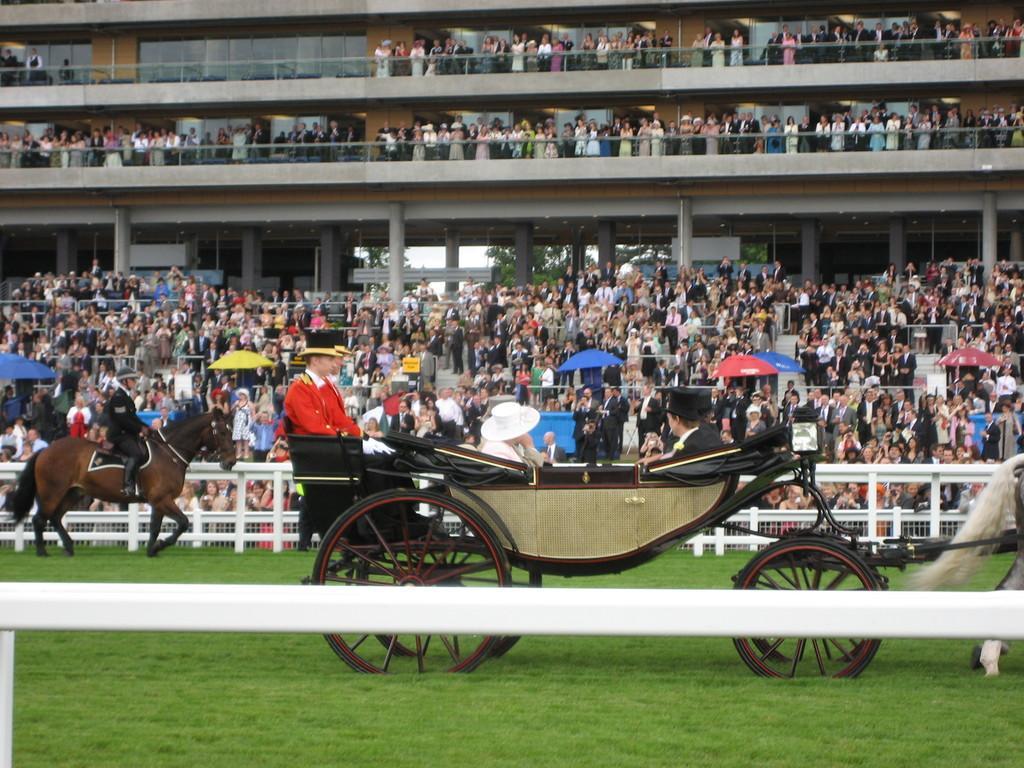Could you give a brief overview of what you see in this image? In this picture there are group of people sitting in the cart. At the back there is a person sitting and riding horse and there are group of people standing and there are umbrellas and trees. In the foreground there is a railing. At the bottom there is grass. 